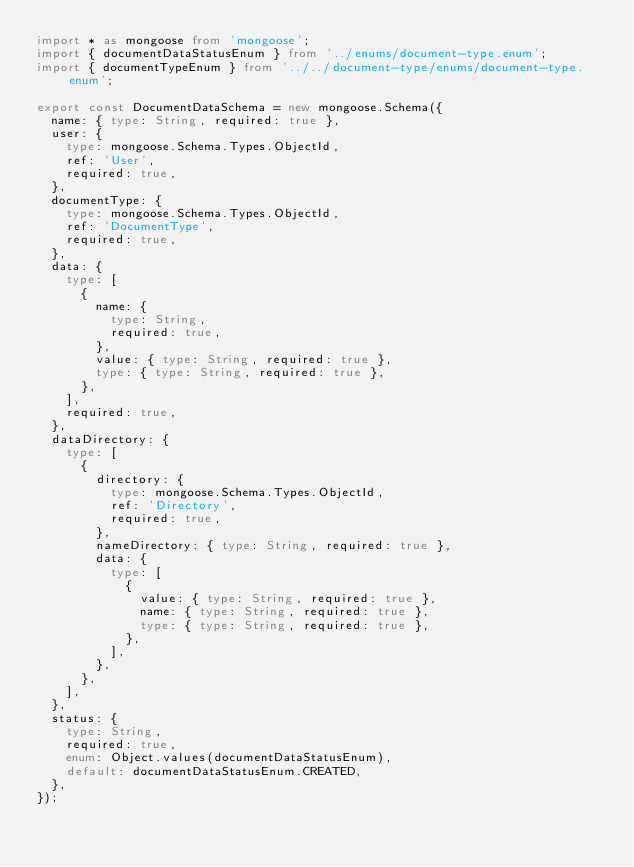Convert code to text. <code><loc_0><loc_0><loc_500><loc_500><_TypeScript_>import * as mongoose from 'mongoose';
import { documentDataStatusEnum } from '../enums/document-type.enum';
import { documentTypeEnum } from '../../document-type/enums/document-type.enum';

export const DocumentDataSchema = new mongoose.Schema({
  name: { type: String, required: true },
  user: {
    type: mongoose.Schema.Types.ObjectId,
    ref: 'User',
    required: true,
  },
  documentType: {
    type: mongoose.Schema.Types.ObjectId,
    ref: 'DocumentType',
    required: true,
  },
  data: {
    type: [
      {
        name: {
          type: String,
          required: true,
        },
        value: { type: String, required: true },
        type: { type: String, required: true },
      },
    ],
    required: true,
  },
  dataDirectory: {
    type: [
      {
        directory: {
          type: mongoose.Schema.Types.ObjectId,
          ref: 'Directory',
          required: true,
        },
        nameDirectory: { type: String, required: true },
        data: {
          type: [
            {
              value: { type: String, required: true },
              name: { type: String, required: true },
              type: { type: String, required: true },
            },
          ],
        },
      },
    ],
  },
  status: {
    type: String,
    required: true,
    enum: Object.values(documentDataStatusEnum),
    default: documentDataStatusEnum.CREATED,
  },
});
</code> 